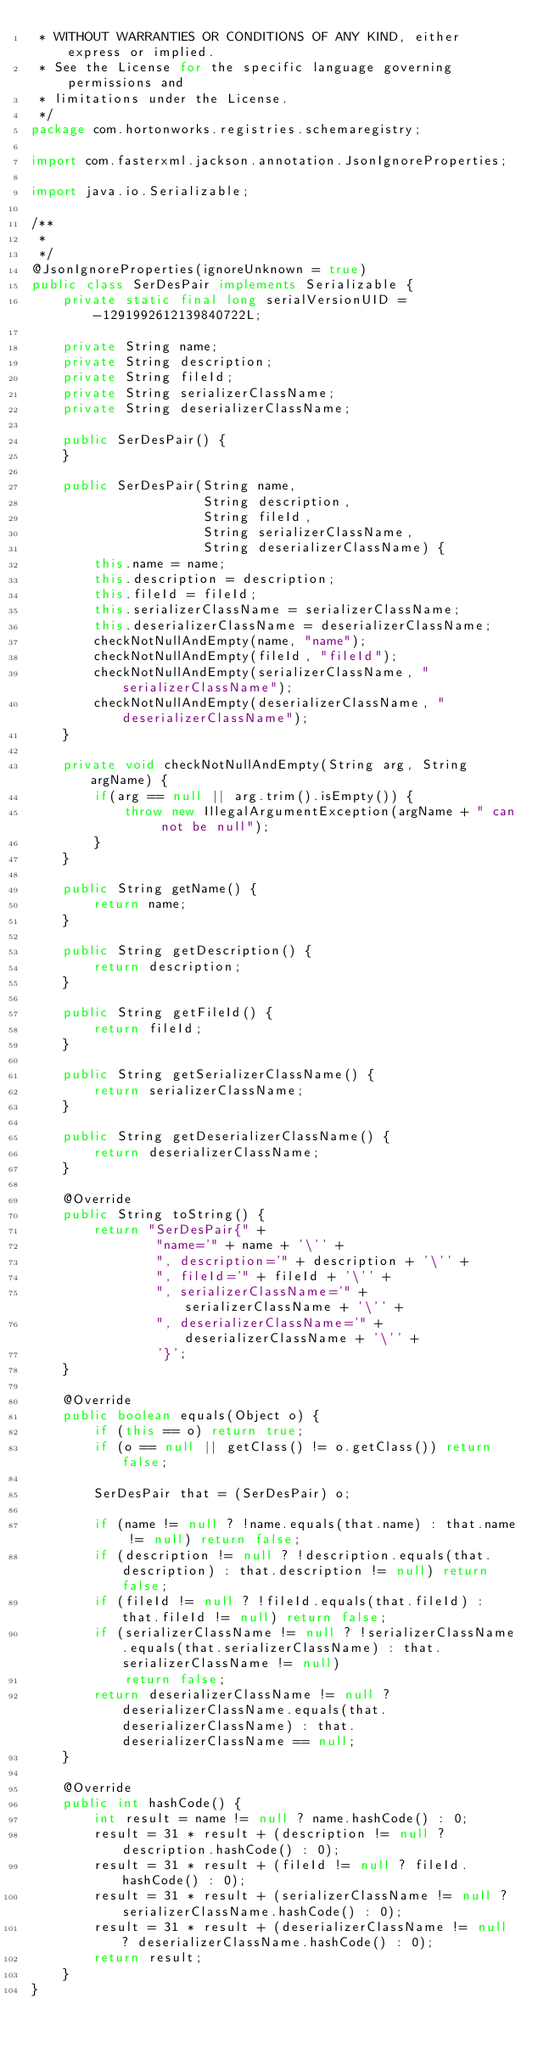<code> <loc_0><loc_0><loc_500><loc_500><_Java_> * WITHOUT WARRANTIES OR CONDITIONS OF ANY KIND, either express or implied.
 * See the License for the specific language governing permissions and
 * limitations under the License.
 */
package com.hortonworks.registries.schemaregistry;

import com.fasterxml.jackson.annotation.JsonIgnoreProperties;

import java.io.Serializable;

/**
 *
 */
@JsonIgnoreProperties(ignoreUnknown = true)
public class SerDesPair implements Serializable {
    private static final long serialVersionUID = -1291992612139840722L;

    private String name;
    private String description;
    private String fileId;
    private String serializerClassName;
    private String deserializerClassName;

    public SerDesPair() {
    }

    public SerDesPair(String name,
                      String description,
                      String fileId,
                      String serializerClassName,
                      String deserializerClassName) {
        this.name = name;
        this.description = description;
        this.fileId = fileId;
        this.serializerClassName = serializerClassName;
        this.deserializerClassName = deserializerClassName;
        checkNotNullAndEmpty(name, "name");
        checkNotNullAndEmpty(fileId, "fileId");
        checkNotNullAndEmpty(serializerClassName, "serializerClassName");
        checkNotNullAndEmpty(deserializerClassName, "deserializerClassName");
    }

    private void checkNotNullAndEmpty(String arg, String argName) {
        if(arg == null || arg.trim().isEmpty()) {
            throw new IllegalArgumentException(argName + " can not be null");
        }
    }

    public String getName() {
        return name;
    }

    public String getDescription() {
        return description;
    }

    public String getFileId() {
        return fileId;
    }

    public String getSerializerClassName() {
        return serializerClassName;
    }

    public String getDeserializerClassName() {
        return deserializerClassName;
    }

    @Override
    public String toString() {
        return "SerDesPair{" +
                "name='" + name + '\'' +
                ", description='" + description + '\'' +
                ", fileId='" + fileId + '\'' +
                ", serializerClassName='" + serializerClassName + '\'' +
                ", deserializerClassName='" + deserializerClassName + '\'' +
                '}';
    }

    @Override
    public boolean equals(Object o) {
        if (this == o) return true;
        if (o == null || getClass() != o.getClass()) return false;

        SerDesPair that = (SerDesPair) o;

        if (name != null ? !name.equals(that.name) : that.name != null) return false;
        if (description != null ? !description.equals(that.description) : that.description != null) return false;
        if (fileId != null ? !fileId.equals(that.fileId) : that.fileId != null) return false;
        if (serializerClassName != null ? !serializerClassName.equals(that.serializerClassName) : that.serializerClassName != null)
            return false;
        return deserializerClassName != null ? deserializerClassName.equals(that.deserializerClassName) : that.deserializerClassName == null;
    }

    @Override
    public int hashCode() {
        int result = name != null ? name.hashCode() : 0;
        result = 31 * result + (description != null ? description.hashCode() : 0);
        result = 31 * result + (fileId != null ? fileId.hashCode() : 0);
        result = 31 * result + (serializerClassName != null ? serializerClassName.hashCode() : 0);
        result = 31 * result + (deserializerClassName != null ? deserializerClassName.hashCode() : 0);
        return result;
    }
}
</code> 